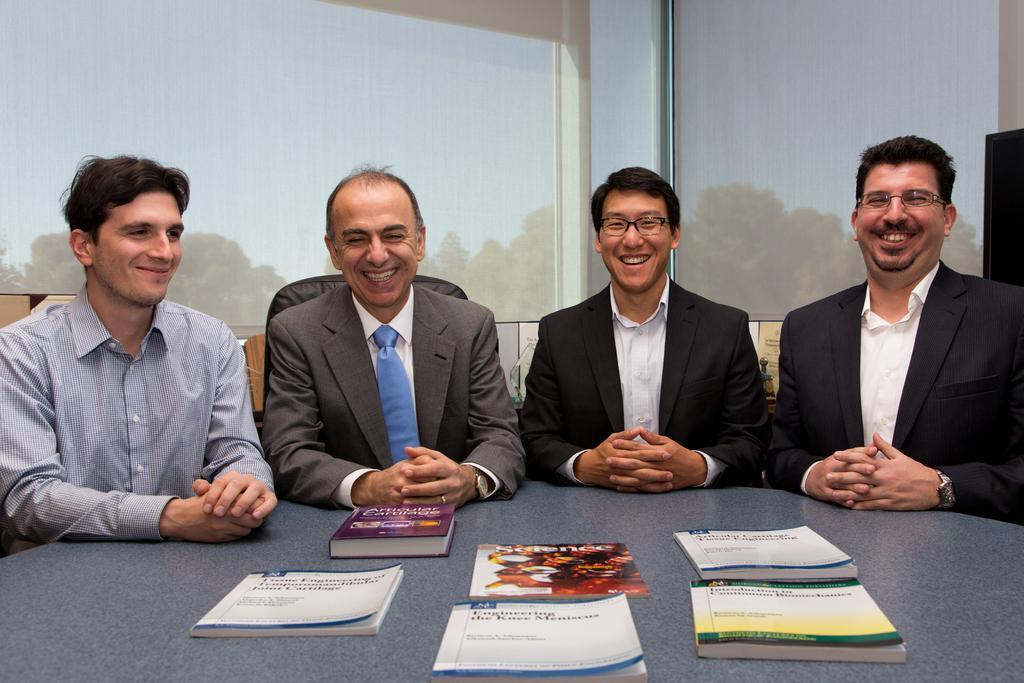In one or two sentences, can you explain what this image depicts? This picture describes a group of four people they are all seated on chairs, and they are all laughing, in front of them we can see some books on the table. In the background we can see some trees. 